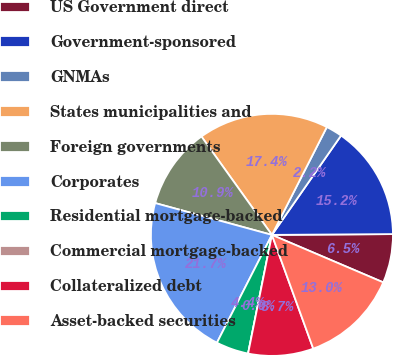<chart> <loc_0><loc_0><loc_500><loc_500><pie_chart><fcel>US Government direct<fcel>Government-sponsored<fcel>GNMAs<fcel>States municipalities and<fcel>Foreign governments<fcel>Corporates<fcel>Residential mortgage-backed<fcel>Commercial mortgage-backed<fcel>Collateralized debt<fcel>Asset-backed securities<nl><fcel>6.52%<fcel>15.22%<fcel>2.18%<fcel>17.39%<fcel>10.87%<fcel>21.73%<fcel>4.35%<fcel>0.0%<fcel>8.7%<fcel>13.04%<nl></chart> 